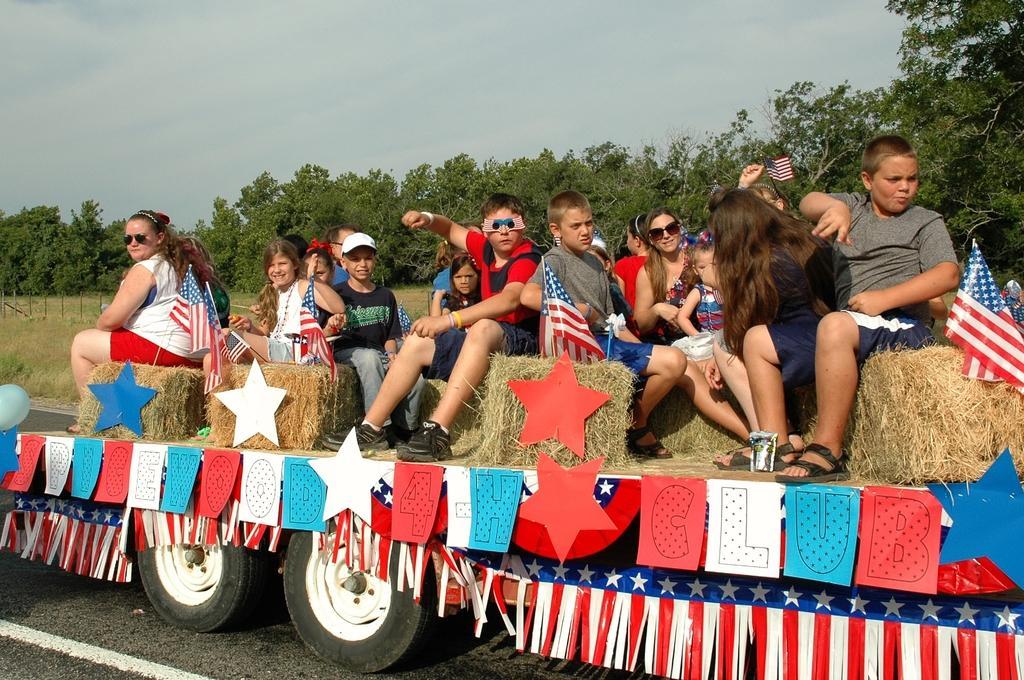Please provide a concise description of this image. In the foreground of the picture there is a vehicle, on the vehicle there are people, flags, ribbons, papers, stars, dry grass. In the center of the picture there are fields, fencing and trees. Sky is cloudy. 